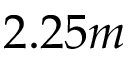<formula> <loc_0><loc_0><loc_500><loc_500>2 . 2 5 m</formula> 